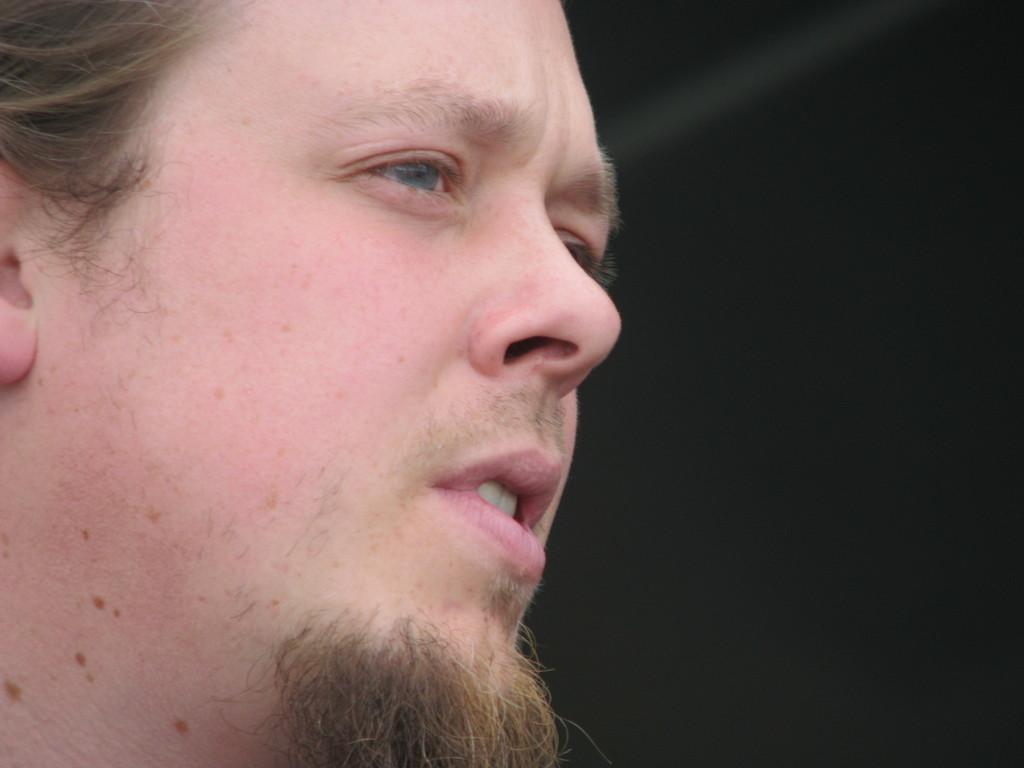What is the main subject of the image? There is a person in the image. Can you describe any specific features of the person's appearance? The person has a French beard. What type of music can be heard playing in the background of the image? There is no music present in the image, as it is a still photograph. 